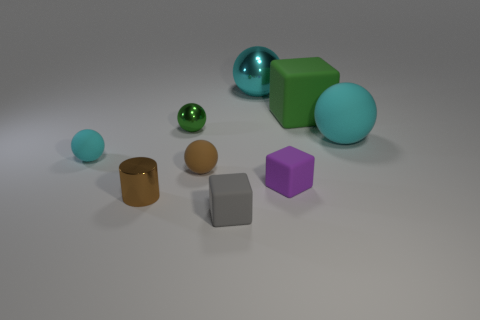Add 1 small red metallic balls. How many objects exist? 10 Subtract all big green matte cubes. How many cubes are left? 2 Subtract 1 balls. How many balls are left? 4 Subtract all green blocks. How many blocks are left? 2 Add 5 small green metallic balls. How many small green metallic balls exist? 6 Subtract 1 gray blocks. How many objects are left? 8 Subtract all spheres. How many objects are left? 4 Subtract all cyan cylinders. Subtract all yellow blocks. How many cylinders are left? 1 Subtract all gray cylinders. How many blue balls are left? 0 Subtract all tiny things. Subtract all tiny metal balls. How many objects are left? 2 